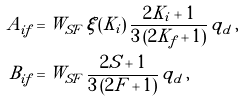Convert formula to latex. <formula><loc_0><loc_0><loc_500><loc_500>A _ { i f } & = W _ { S F } \, \xi ( K _ { i } ) \, \frac { 2 K _ { i } + 1 } { 3 \, ( 2 K _ { f } + 1 ) } \, q _ { d } \, , \\ B _ { i f } & = W _ { S F } \, \frac { 2 S + 1 } { 3 \, ( 2 F + 1 ) } \, q _ { d } \, ,</formula> 